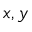Convert formula to latex. <formula><loc_0><loc_0><loc_500><loc_500>x , y</formula> 